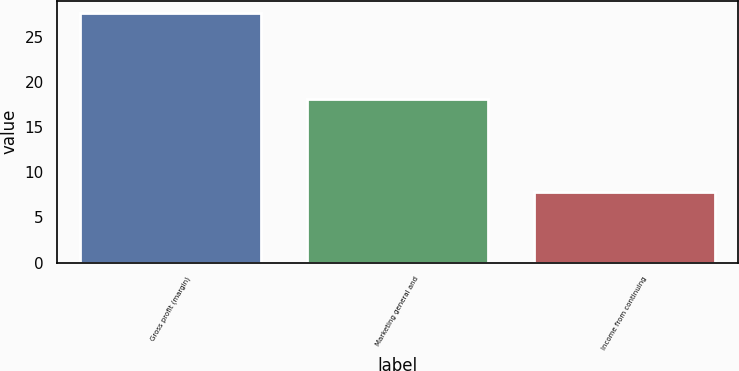<chart> <loc_0><loc_0><loc_500><loc_500><bar_chart><fcel>Gross profit (margin)<fcel>Marketing general and<fcel>Income from continuing<nl><fcel>27.6<fcel>18.1<fcel>7.8<nl></chart> 